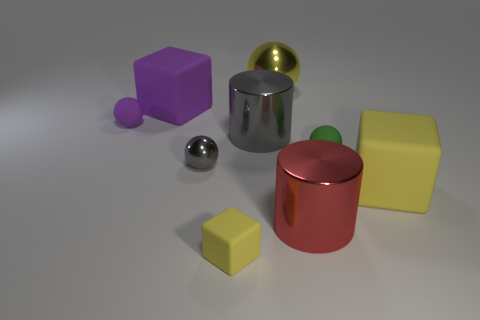Are there more yellow matte things on the left side of the red cylinder than tiny purple things in front of the tiny shiny thing?
Your answer should be very brief. Yes. There is a matte sphere in front of the purple sphere; is its color the same as the small shiny ball?
Your answer should be very brief. No. Is there anything else of the same color as the big metal ball?
Provide a succinct answer. Yes. Is the number of yellow metal objects that are behind the green thing greater than the number of yellow shiny cubes?
Ensure brevity in your answer.  Yes. Is the purple rubber ball the same size as the gray metal sphere?
Offer a terse response. Yes. There is a green thing that is the same shape as the small gray shiny object; what is its material?
Give a very brief answer. Rubber. How many yellow things are tiny shiny balls or large rubber cubes?
Give a very brief answer. 1. What is the cylinder that is left of the yellow metallic thing made of?
Keep it short and to the point. Metal. Is the number of small yellow rubber blocks greater than the number of yellow objects?
Provide a succinct answer. No. Is the shape of the small rubber object on the right side of the large gray cylinder the same as  the tiny purple matte thing?
Provide a succinct answer. Yes. 